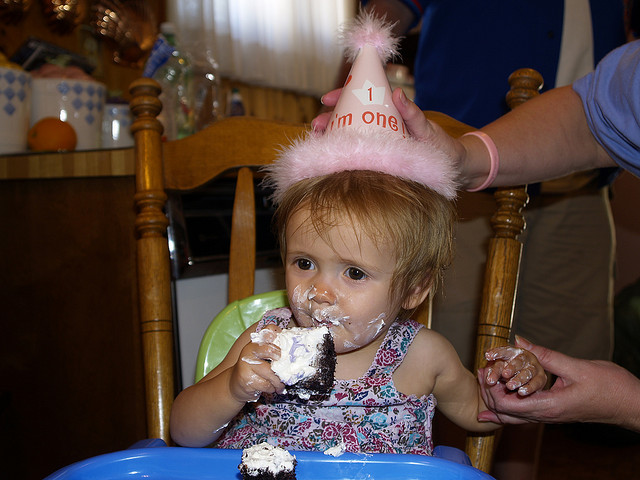Identify and read out the text in this image. 1 im one 